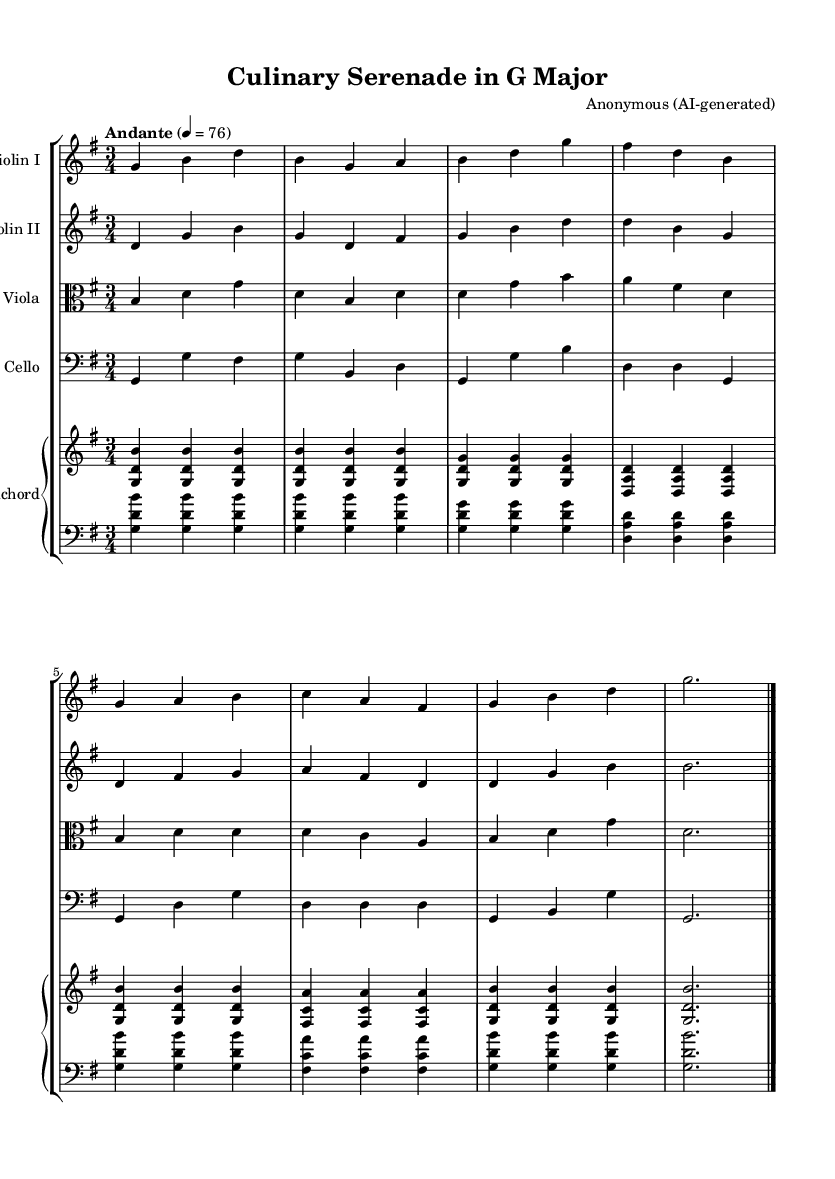What is the key signature of this music? The key signature is G major, which has one sharp. This can be identified by looking at the beginning of the staff where the key signature is indicated.
Answer: G major What is the time signature of this music? The time signature is 3/4, which means there are three beats in a measure and the quarter note gets one beat. This is located near the beginning of the music above the staff lines.
Answer: 3/4 What is the tempo marking in this piece? The tempo marking is "Andante," indicating a moderately slow tempo. This is written at the beginning of the score, usually after the time signature and clef.
Answer: Andante How many instruments are included in this score? There are five instruments: two violins, one viola, one cello, and one harpsichord. This can be determined by observing the separate staves labeled for each instrument in the score.
Answer: Five Which instrument plays the lowest pitch in this piece? The cello plays the lowest pitch, indicated by its position in the bass clef on the score. By examining the clefs and the notes on the staff, it's clear that the cello's range is below that of the other instruments.
Answer: Cello What kind of ensemble is represented in this sheet music? The ensemble is a Baroque chamber music group since it consists of strings and a harpsichord, which were typical in chamber settings during the Baroque period. This understanding is based on the instruments listed in the score.
Answer: Baroque chamber music 